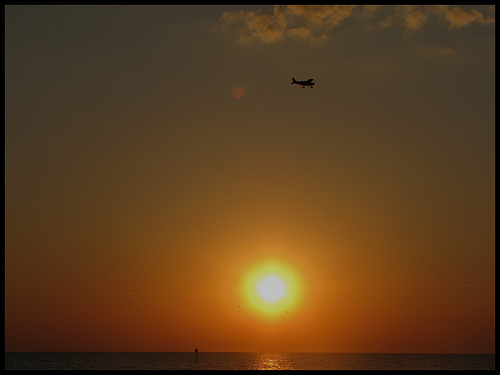<image>Is the sun setting or rising? I am not sure if the sun is setting or rising. What direction is the airplane flying? I don't know what direction the airplane is flying. It could be any direction including east, north, south, or west. Is the sun setting or rising? The sun is setting. What direction is the airplane flying? I don't know the direction in which the airplane is flying. It can be flying south, west, north, or east. 